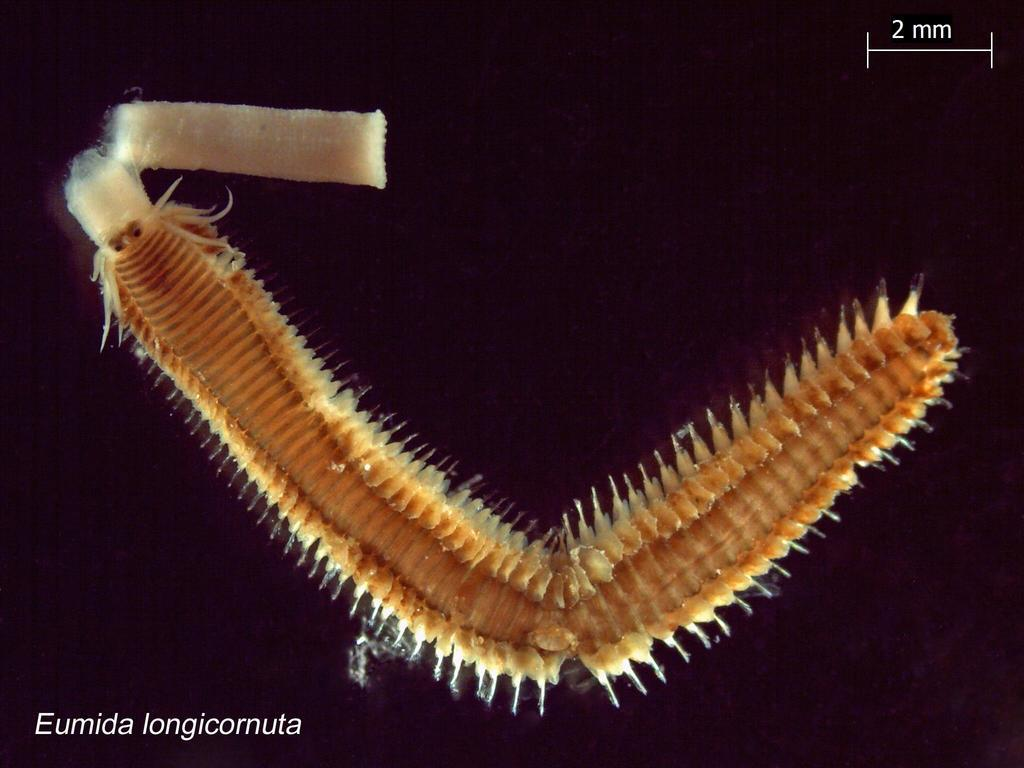What type of creature can be seen in the image? There is an insect in the image. What color is present in the background of the image? There is a black color in the background of the image. What type of soup is being served in the image? There is no soup present in the image; it features an insect and a black background. What type of writing instrument is visible in the image? There is no writing instrument, such as a quill, present in the image. 